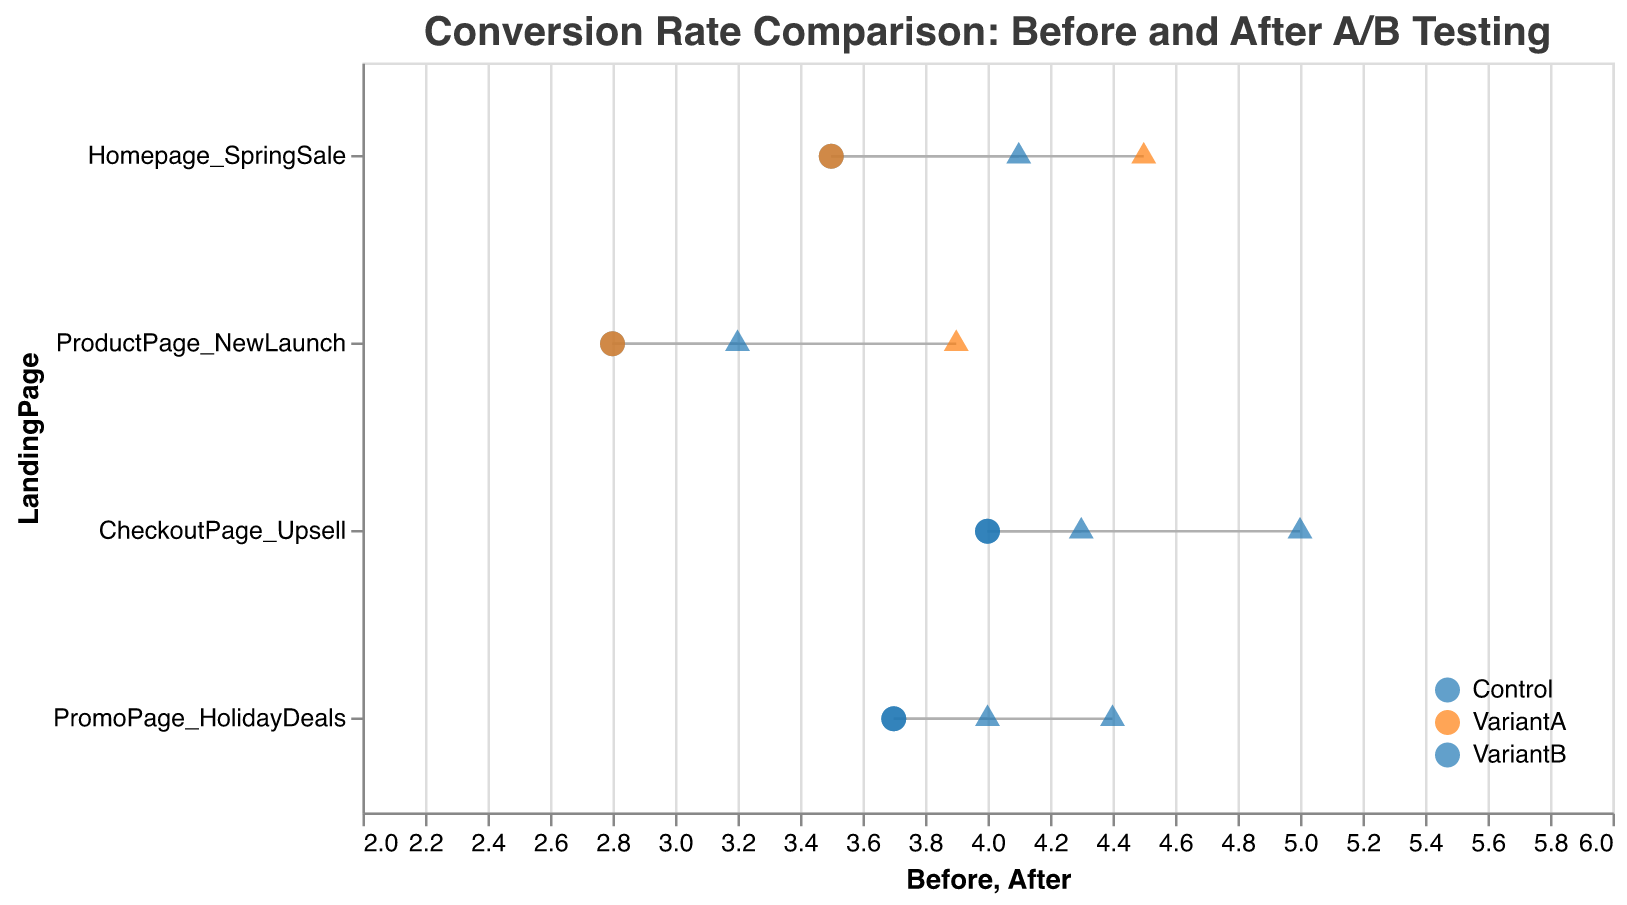What is the title of the figure? The title is displayed at the top of the graph. It summarizes the content of the graph, which is comparing conversion rates before and after A/B testing.
Answer: Conversion Rate Comparison: Before and After A/B Testing How many landing pages are analyzed in the figure? Count the unique categories along the y-axis, which represents the landing pages. The figure includes four unique landing pages.
Answer: 4 Which landing page and test group combination showed the highest conversion rate after A/B testing? Look for the point farthest to the right (largest value of "After") for each test group. The "CheckoutPage_Upsell" with "VariantB" has the highest conversion rate after A/B testing.
Answer: CheckoutPage_Upsell, VariantB What is the conversion rate increase for "Homepage_SpringSale" VariantA? Find the "Before" and "After" values for "Homepage_SpringSale" VariantA. The conversion rate increases from 3.5 to 4.5. Subtract the before value from the after value.
Answer: 1.0 Which landing page had the smallest conversion rate change in the control group? Compare the differences between "Before" and "After" values for all control groups. The smallest change is seen in "PromoPage_HolidayDeals" which increased from 3.7 to 4.0.
Answer: PromoPage_HolidayDeals What is the average conversion rate before A/B testing for the "ProductPage_NewLaunch"? Find the "Before" values for both the Control and VariantA of "ProductPage_NewLaunch". The values are 2.8 for both. Calculate the average: (2.8 + 2.8) / 2.
Answer: 2.8 Which landing page improved its conversion rate the most after A/B testing? Calculate the difference between the "Before" and "After" values for each landing page and test group. "CheckoutPage_Upsell" with "VariantB" improved the most from 4.0 to 5.0, an increase of 1.0.
Answer: CheckoutPage_Upsell, VariantB In general, did the variants or the control groups see a greater increase in conversion rates? Compare the differences between "Before" and "After" for variants versus control groups. Variants show generally larger increases in conversion rates. E.g., "Homepage_SpringSale" VariantA (increase of 1.0) versus Control (increase of 0.6).
Answer: Variants Which page had the highest conversion rate before A/B testing? Look for the highest "Before" value on the x-axis. "CheckoutPage_Upsell" has the highest conversion rate before A/B testing at 4.0.
Answer: CheckoutPage_Upsell 